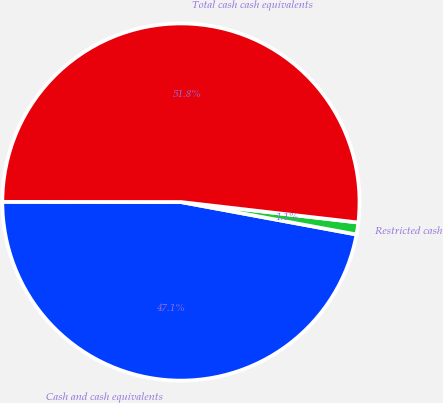Convert chart to OTSL. <chart><loc_0><loc_0><loc_500><loc_500><pie_chart><fcel>Cash and cash equivalents<fcel>Restricted cash<fcel>Total cash cash equivalents<nl><fcel>47.1%<fcel>1.08%<fcel>51.81%<nl></chart> 